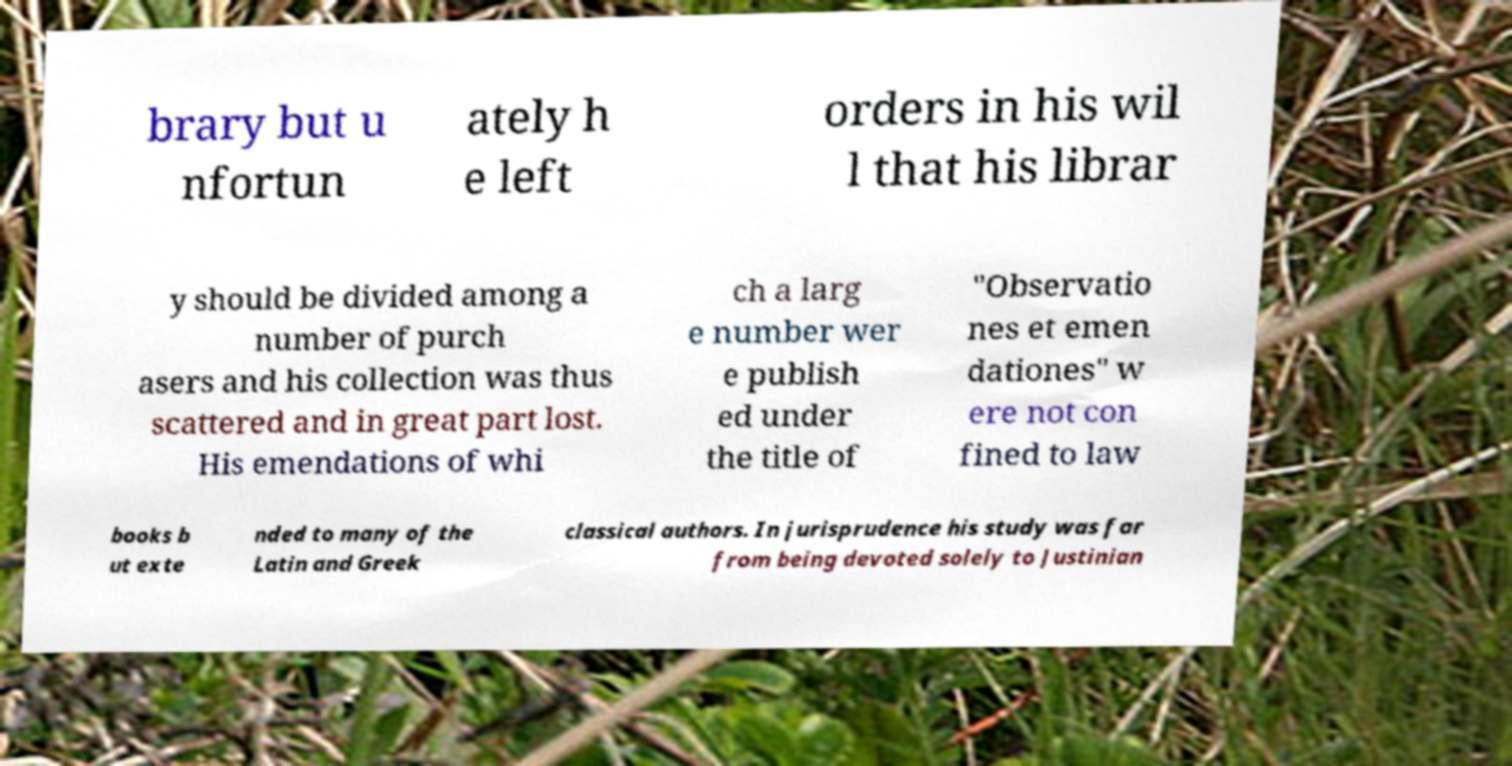There's text embedded in this image that I need extracted. Can you transcribe it verbatim? brary but u nfortun ately h e left orders in his wil l that his librar y should be divided among a number of purch asers and his collection was thus scattered and in great part lost. His emendations of whi ch a larg e number wer e publish ed under the title of "Observatio nes et emen dationes" w ere not con fined to law books b ut exte nded to many of the Latin and Greek classical authors. In jurisprudence his study was far from being devoted solely to Justinian 